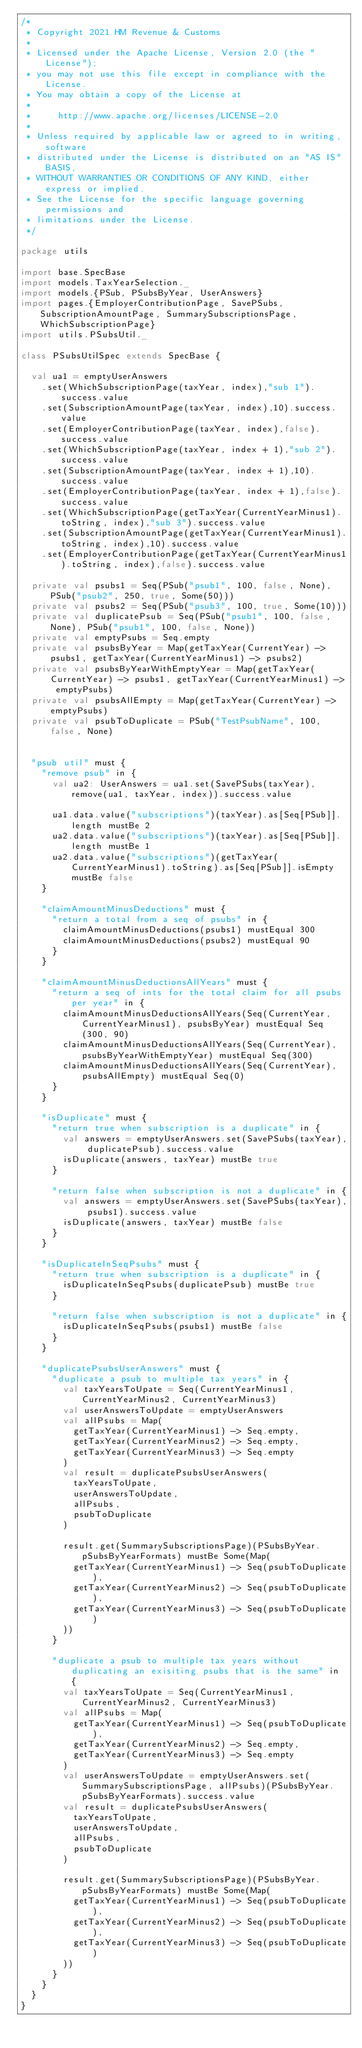Convert code to text. <code><loc_0><loc_0><loc_500><loc_500><_Scala_>/*
 * Copyright 2021 HM Revenue & Customs
 *
 * Licensed under the Apache License, Version 2.0 (the "License");
 * you may not use this file except in compliance with the License.
 * You may obtain a copy of the License at
 *
 *     http://www.apache.org/licenses/LICENSE-2.0
 *
 * Unless required by applicable law or agreed to in writing, software
 * distributed under the License is distributed on an "AS IS" BASIS,
 * WITHOUT WARRANTIES OR CONDITIONS OF ANY KIND, either express or implied.
 * See the License for the specific language governing permissions and
 * limitations under the License.
 */

package utils

import base.SpecBase
import models.TaxYearSelection._
import models.{PSub, PSubsByYear, UserAnswers}
import pages.{EmployerContributionPage, SavePSubs, SubscriptionAmountPage, SummarySubscriptionsPage, WhichSubscriptionPage}
import utils.PSubsUtil._

class PSubsUtilSpec extends SpecBase {

  val ua1 = emptyUserAnswers
    .set(WhichSubscriptionPage(taxYear, index),"sub 1").success.value
    .set(SubscriptionAmountPage(taxYear, index),10).success.value
    .set(EmployerContributionPage(taxYear, index),false).success.value
    .set(WhichSubscriptionPage(taxYear, index + 1),"sub 2").success.value
    .set(SubscriptionAmountPage(taxYear, index + 1),10).success.value
    .set(EmployerContributionPage(taxYear, index + 1),false).success.value
    .set(WhichSubscriptionPage(getTaxYear(CurrentYearMinus1).toString, index),"sub 3").success.value
    .set(SubscriptionAmountPage(getTaxYear(CurrentYearMinus1).toString, index),10).success.value
    .set(EmployerContributionPage(getTaxYear(CurrentYearMinus1).toString, index),false).success.value

  private val psubs1 = Seq(PSub("psub1", 100, false, None), PSub("psub2", 250, true, Some(50)))
  private val psubs2 = Seq(PSub("psub3", 100, true, Some(10)))
  private val duplicatePsub = Seq(PSub("psub1", 100, false, None), PSub("psub1", 100, false, None))
  private val emptyPsubs = Seq.empty
  private val psubsByYear = Map(getTaxYear(CurrentYear) -> psubs1, getTaxYear(CurrentYearMinus1) -> psubs2)
  private val psubsByYearWithEmptyYear = Map(getTaxYear(CurrentYear) -> psubs1, getTaxYear(CurrentYearMinus1) -> emptyPsubs)
  private val psubsAllEmpty = Map(getTaxYear(CurrentYear) -> emptyPsubs)
  private val psubToDuplicate = PSub("TestPsubName", 100, false, None)


  "psub util" must {
    "remove psub" in {
      val ua2: UserAnswers = ua1.set(SavePSubs(taxYear), remove(ua1, taxYear, index)).success.value

      ua1.data.value("subscriptions")(taxYear).as[Seq[PSub]].length mustBe 2
      ua2.data.value("subscriptions")(taxYear).as[Seq[PSub]].length mustBe 1
      ua2.data.value("subscriptions")(getTaxYear(CurrentYearMinus1).toString).as[Seq[PSub]].isEmpty mustBe false
    }

    "claimAmountMinusDeductions" must {
      "return a total from a seq of psubs" in {
        claimAmountMinusDeductions(psubs1) mustEqual 300
        claimAmountMinusDeductions(psubs2) mustEqual 90
      }
    }

    "claimAmountMinusDeductionsAllYears" must {
      "return a seq of ints for the total claim for all psubs per year" in {
        claimAmountMinusDeductionsAllYears(Seq(CurrentYear, CurrentYearMinus1), psubsByYear) mustEqual Seq(300, 90)
        claimAmountMinusDeductionsAllYears(Seq(CurrentYear), psubsByYearWithEmptyYear) mustEqual Seq(300)
        claimAmountMinusDeductionsAllYears(Seq(CurrentYear), psubsAllEmpty) mustEqual Seq(0)
      }
    }

    "isDuplicate" must {
      "return true when subscription is a duplicate" in {
        val answers = emptyUserAnswers.set(SavePSubs(taxYear), duplicatePsub).success.value
        isDuplicate(answers, taxYear) mustBe true
      }

      "return false when subscription is not a duplicate" in {
        val answers = emptyUserAnswers.set(SavePSubs(taxYear), psubs1).success.value
        isDuplicate(answers, taxYear) mustBe false
      }
    }

    "isDuplicateInSeqPsubs" must {
      "return true when subscription is a duplicate" in {
        isDuplicateInSeqPsubs(duplicatePsub) mustBe true
      }

      "return false when subscription is not a duplicate" in {
        isDuplicateInSeqPsubs(psubs1) mustBe false
      }
    }

    "duplicatePsubsUserAnswers" must {
      "duplicate a psub to multiple tax years" in {
        val taxYearsToUpate = Seq(CurrentYearMinus1, CurrentYearMinus2, CurrentYearMinus3)
        val userAnswersToUpdate = emptyUserAnswers
        val allPsubs = Map(
          getTaxYear(CurrentYearMinus1) -> Seq.empty,
          getTaxYear(CurrentYearMinus2) -> Seq.empty,
          getTaxYear(CurrentYearMinus3) -> Seq.empty
        )
        val result = duplicatePsubsUserAnswers(
          taxYearsToUpate,
          userAnswersToUpdate,
          allPsubs,
          psubToDuplicate
        )

        result.get(SummarySubscriptionsPage)(PSubsByYear.pSubsByYearFormats) mustBe Some(Map(
          getTaxYear(CurrentYearMinus1) -> Seq(psubToDuplicate),
          getTaxYear(CurrentYearMinus2) -> Seq(psubToDuplicate),
          getTaxYear(CurrentYearMinus3) -> Seq(psubToDuplicate)
        ))
      }

      "duplicate a psub to multiple tax years without duplicating an exisiting psubs that is the same" in {
        val taxYearsToUpate = Seq(CurrentYearMinus1, CurrentYearMinus2, CurrentYearMinus3)
        val allPsubs = Map(
          getTaxYear(CurrentYearMinus1) -> Seq(psubToDuplicate),
          getTaxYear(CurrentYearMinus2) -> Seq.empty,
          getTaxYear(CurrentYearMinus3) -> Seq.empty
        )
        val userAnswersToUpdate = emptyUserAnswers.set(SummarySubscriptionsPage, allPsubs)(PSubsByYear.pSubsByYearFormats).success.value
        val result = duplicatePsubsUserAnswers(
          taxYearsToUpate,
          userAnswersToUpdate,
          allPsubs,
          psubToDuplicate
        )

        result.get(SummarySubscriptionsPage)(PSubsByYear.pSubsByYearFormats) mustBe Some(Map(
          getTaxYear(CurrentYearMinus1) -> Seq(psubToDuplicate),
          getTaxYear(CurrentYearMinus2) -> Seq(psubToDuplicate),
          getTaxYear(CurrentYearMinus3) -> Seq(psubToDuplicate)
        ))
      }
    }
  }
}
</code> 